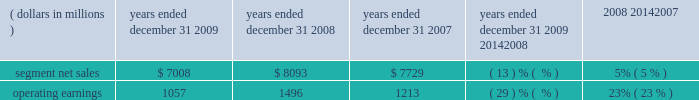Management 2019s discussion and analysis of financial condition and results of operations in 2008 , sales to the segment 2019s top five customers represented approximately 45% ( 45 % ) of the segment 2019s net sales .
The segment 2019s backlog was $ 2.3 billion at december 31 , 2008 , compared to $ 2.6 billion at december 31 , 2007 .
In 2008 , our digital video customers significantly increased their purchases of the segment 2019s products and services , primarily due to increased demand for digital entertainment devices , particularly ip and hd/dvr devices .
In february 2008 , the segment acquired the assets related to digital cable set-top products of zhejiang dahua digital technology co. , ltd and hangzhou image silicon ( known collectively as dahua digital ) , a developer , manufacturer and marketer of cable set-tops and related low-cost integrated circuits for the emerging chinese cable business .
The acquisition helped the segment strengthen its position in the rapidly growing cable market in china .
Enterprise mobility solutions segment the enterprise mobility solutions segment designs , manufactures , sells , installs and services analog and digital two-way radios , wireless lan and security products , voice and data communications products and systems for private networks , wireless broadband systems and end-to-end enterprise mobility solutions to a wide range of customers , including government and public safety agencies ( which , together with all sales to distributors of two-way communication products , are referred to as the 2018 2018government and public safety market 2019 2019 ) , as well as retail , energy and utilities , transportation , manufacturing , healthcare and other commercial customers ( which , collectively , are referred to as the 2018 2018commercial enterprise market 2019 2019 ) .
In 2009 , the segment 2019s net sales represented 32% ( 32 % ) of the company 2019s consolidated net sales , compared to 27% ( 27 % ) in 2008 and 21% ( 21 % ) in 2007 .
Years ended december 31 percent change ( dollars in millions ) 2009 2008 2007 2009 20142008 2008 20142007 .
Segment results 20142009 compared to 2008 in 2009 , the segment 2019s net sales were $ 7.0 billion , a decrease of 13% ( 13 % ) compared to net sales of $ 8.1 billion in 2008 .
The 13% ( 13 % ) decrease in net sales reflects a 21% ( 21 % ) decrease in net sales to the commercial enterprise market and a 10% ( 10 % ) decrease in net sales to the government and public safety market .
The decrease in net sales to the commercial enterprise market reflects decreased net sales in all regions .
The decrease in net sales to the government and public safety market was primarily driven by decreased net sales in emea , north america and latin america , partially offset by higher net sales in asia .
The segment 2019s overall net sales were lower in north america , emea and latin america and higher in asia the segment had operating earnings of $ 1.1 billion in 2009 , a decrease of 29% ( 29 % ) compared to operating earnings of $ 1.5 billion in 2008 .
The decrease in operating earnings was primarily due to a decrease in gross margin , driven by the 13% ( 13 % ) decrease in net sales and an unfavorable product mix .
Also contributing to the decrease in operating earnings was an increase in reorganization of business charges , relating primarily to higher employee severance costs .
These factors were partially offset by decreased sg&a expenses and r&d expenditures , primarily related to savings from cost-reduction initiatives .
As a percentage of net sales in 2009 as compared 2008 , gross margin decreased and r&d expenditures and sg&a expenses increased .
Net sales in north america continued to comprise a significant portion of the segment 2019s business , accounting for approximately 58% ( 58 % ) of the segment 2019s net sales in 2009 , compared to approximately 57% ( 57 % ) in 2008 .
The regional shift in 2009 as compared to 2008 reflects a 16% ( 16 % ) decline in net sales outside of north america and a 12% ( 12 % ) decline in net sales in north america .
The segment 2019s backlog was $ 2.4 billion at both december 31 , 2009 and december 31 , 2008 .
In our government and public safety market , we see a continued emphasis on mission-critical communication and homeland security solutions .
In 2009 , we led market innovation through the continued success of our mototrbo line and the delivery of the apx fffd family of products .
While spending by end customers in the segment 2019s government and public safety market is affected by government budgets at the national , state and local levels , we continue to see demand for large-scale mission critical communications systems .
In 2009 , we had significant wins across the globe , including several city and statewide communications systems in the united states , and continued success winning competitive projects with our tetra systems in europe , the middle east .
In 2007 what was the ratio of the segment net sales to the operating earnings? 
Computations: (7729 / 1213)
Answer: 6.37181. 